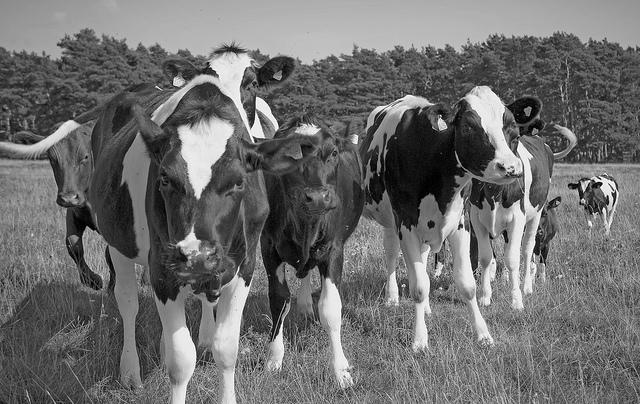How many cows are there?
Answer briefly. 8. What is on the ground?
Keep it brief. Grass. Do they all have the same white strip on their face?
Short answer required. No. Is this a family of elephants?
Answer briefly. No. Are there any cows with horns?
Write a very short answer. No. 